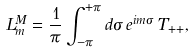<formula> <loc_0><loc_0><loc_500><loc_500>L _ { m } ^ { M } = \frac { 1 } { \pi } \int _ { - \pi } ^ { + \pi } d \sigma \, e ^ { i m \sigma } \, T _ { + + } ,</formula> 